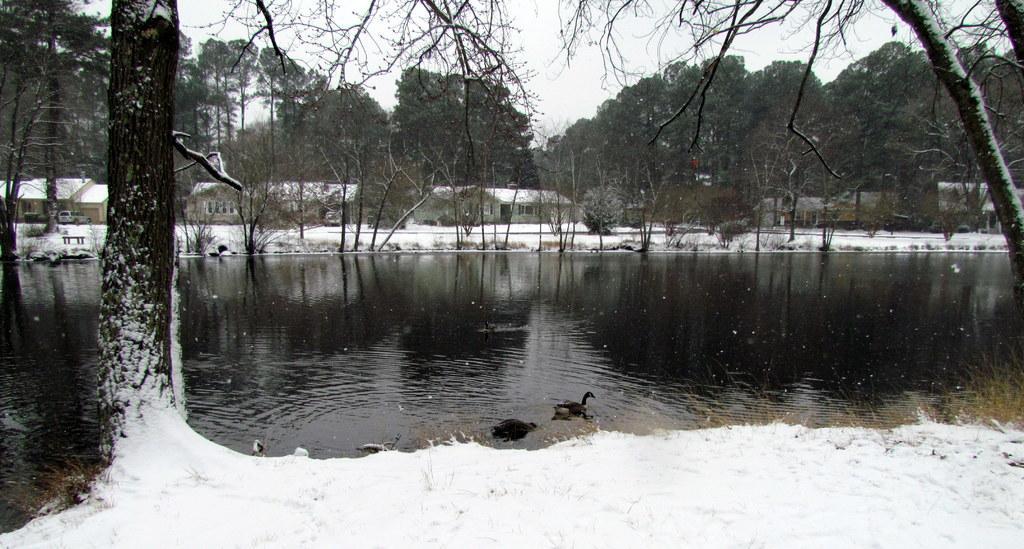How would you summarize this image in a sentence or two? In the image we can see there are birds in the water. There is a snow, grass, trees, sky, vehicle, bench and house. 